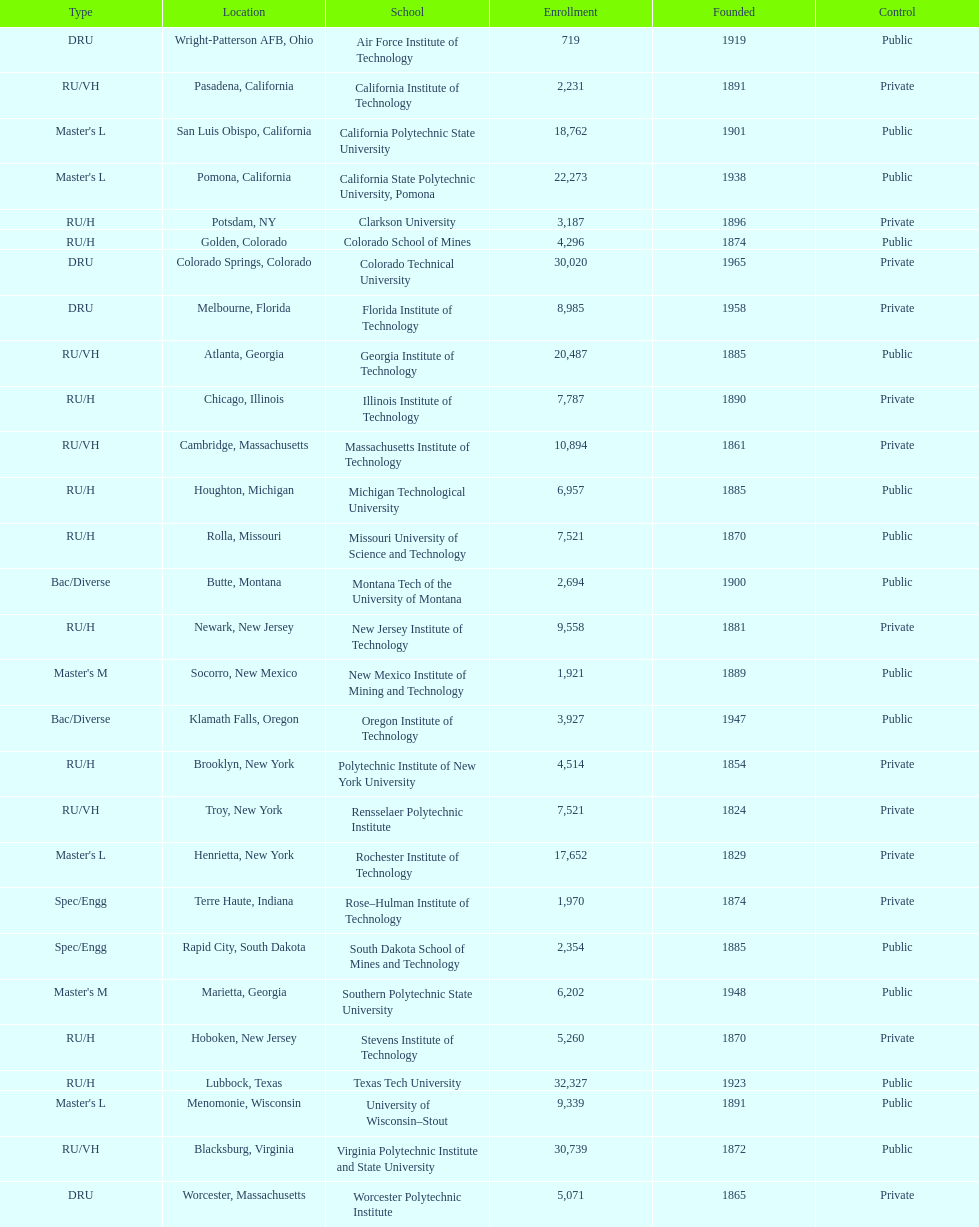What is the total number of schools listed in the table? 28. 